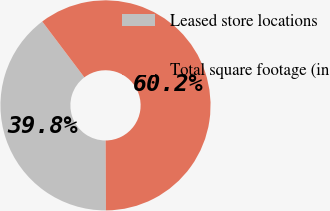<chart> <loc_0><loc_0><loc_500><loc_500><pie_chart><fcel>Leased store locations<fcel>Total square footage (in<nl><fcel>39.78%<fcel>60.22%<nl></chart> 